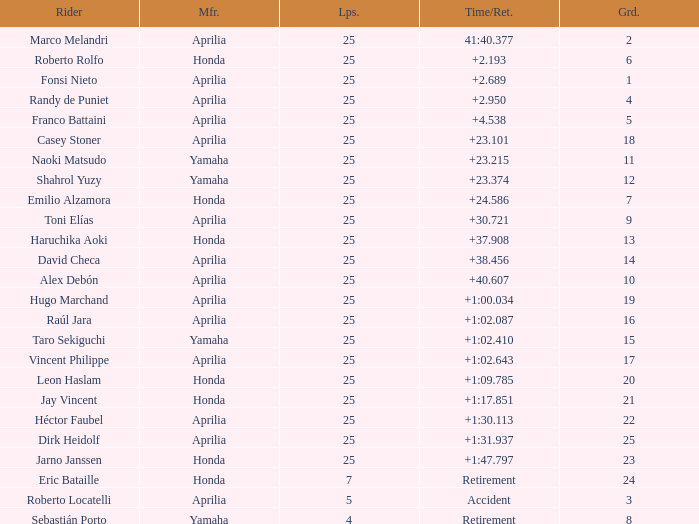Which Manufacturer has a Time/Retired of accident? Aprilia. 